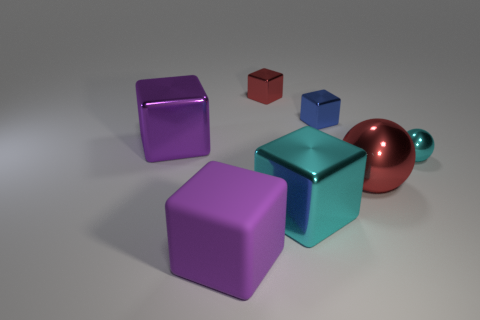Is the color of the small sphere the same as the big metal block in front of the small cyan shiny ball?
Ensure brevity in your answer.  Yes. There is another large object that is the same color as the rubber thing; what is its material?
Offer a very short reply. Metal. How big is the red shiny object behind the shiny cube that is to the left of the red metal object that is to the left of the red metallic sphere?
Your answer should be very brief. Small. Are there fewer small green matte objects than purple matte things?
Provide a short and direct response. Yes. What color is the big metal object that is the same shape as the tiny cyan thing?
Provide a succinct answer. Red. Is there a small metal ball that is right of the block right of the big cyan object that is to the right of the red block?
Give a very brief answer. Yes. Is the blue metal thing the same shape as the large cyan thing?
Offer a terse response. Yes. Is the number of big purple things that are in front of the cyan cube less than the number of shiny things?
Your response must be concise. Yes. There is a small thing in front of the big purple block that is behind the small shiny thing that is on the right side of the red ball; what color is it?
Give a very brief answer. Cyan. What number of rubber things are tiny blocks or large green spheres?
Your answer should be compact. 0. 